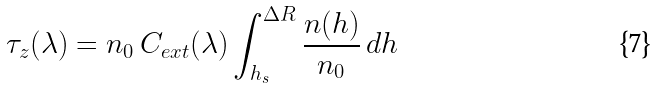<formula> <loc_0><loc_0><loc_500><loc_500>\tau _ { z } ( \lambda ) = n _ { 0 } \, C _ { e x t } ( \lambda ) \int _ { h _ { s } } ^ { \Delta R } \frac { n ( h ) } { n _ { 0 } } \, d h</formula> 